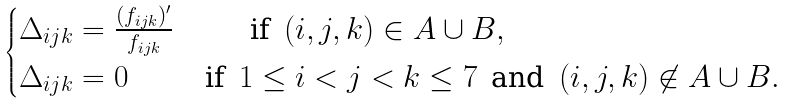<formula> <loc_0><loc_0><loc_500><loc_500>\begin{cases} \Delta _ { i j k } = \frac { ( f _ { i j k } ) ^ { \prime } } { f _ { i j k } } \quad \, \quad \, \text { if } \, ( i , j , k ) \in A \cup B , \\ \Delta _ { i j k } = 0 \quad \, \quad \, \text { if } \, 1 \leq i < j < k \leq 7 \, \text { and } \, ( i , j , k ) \not \in A \cup B . \end{cases}</formula> 